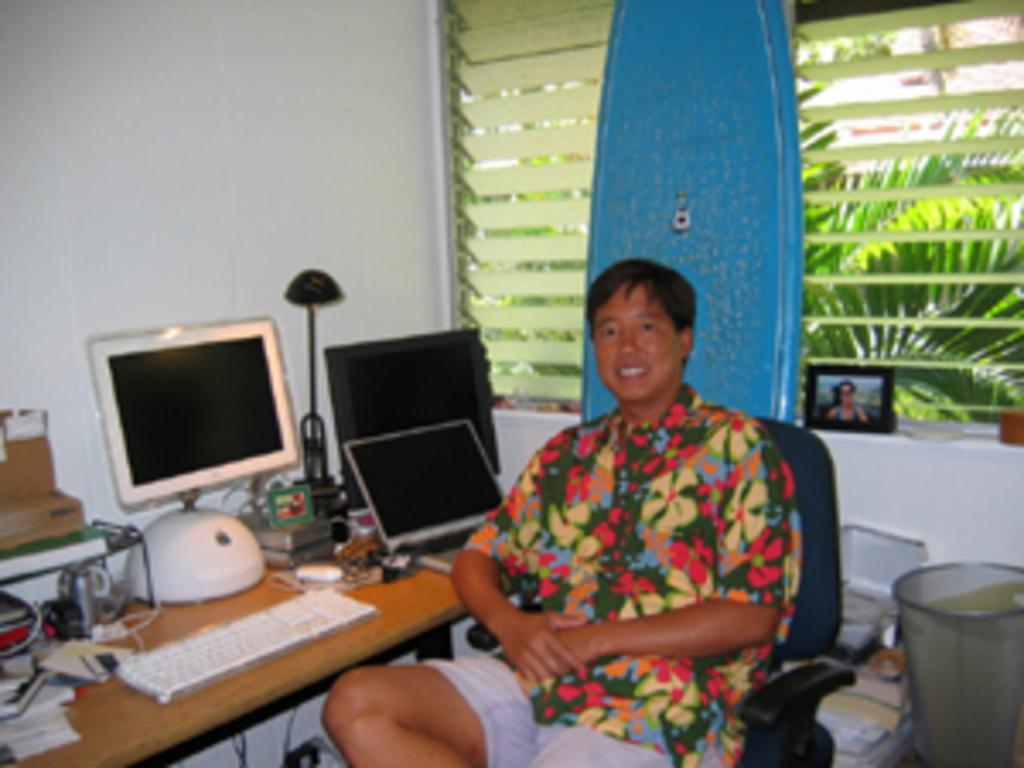In one or two sentences, can you explain what this image depicts? In this image there is one person who is sitting in the middle of the image in front of him there is one table. On the left side there is one computer and keyboard on the left side of the bottom corner there are some books and on the right side of the top corner there is one window and there are some plants and in the middle of the image there is one photo frame and in the left side of the top corner there is one wall. 